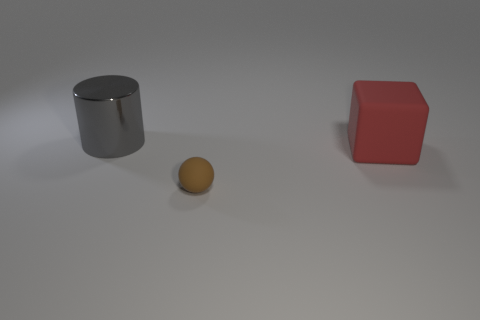What objects are shown in the image, and what colors are they? The image displays three objects: a shiny metallic cylinder, a matte red cube, and a yellowish sphere. The cylinder reflects light, suggesting a metal or chrome finish, while the cube and sphere have a solid color and a more diffuse reflection, indicating non-metallic materials. 